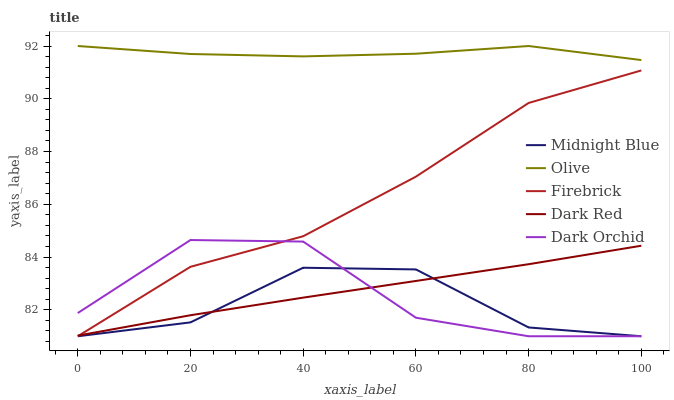Does Midnight Blue have the minimum area under the curve?
Answer yes or no. Yes. Does Olive have the maximum area under the curve?
Answer yes or no. Yes. Does Dark Red have the minimum area under the curve?
Answer yes or no. No. Does Dark Red have the maximum area under the curve?
Answer yes or no. No. Is Dark Red the smoothest?
Answer yes or no. Yes. Is Dark Orchid the roughest?
Answer yes or no. Yes. Is Firebrick the smoothest?
Answer yes or no. No. Is Firebrick the roughest?
Answer yes or no. No. Does Firebrick have the lowest value?
Answer yes or no. Yes. Does Dark Red have the lowest value?
Answer yes or no. No. Does Olive have the highest value?
Answer yes or no. Yes. Does Dark Red have the highest value?
Answer yes or no. No. Is Dark Red less than Olive?
Answer yes or no. Yes. Is Olive greater than Firebrick?
Answer yes or no. Yes. Does Midnight Blue intersect Dark Orchid?
Answer yes or no. Yes. Is Midnight Blue less than Dark Orchid?
Answer yes or no. No. Is Midnight Blue greater than Dark Orchid?
Answer yes or no. No. Does Dark Red intersect Olive?
Answer yes or no. No. 